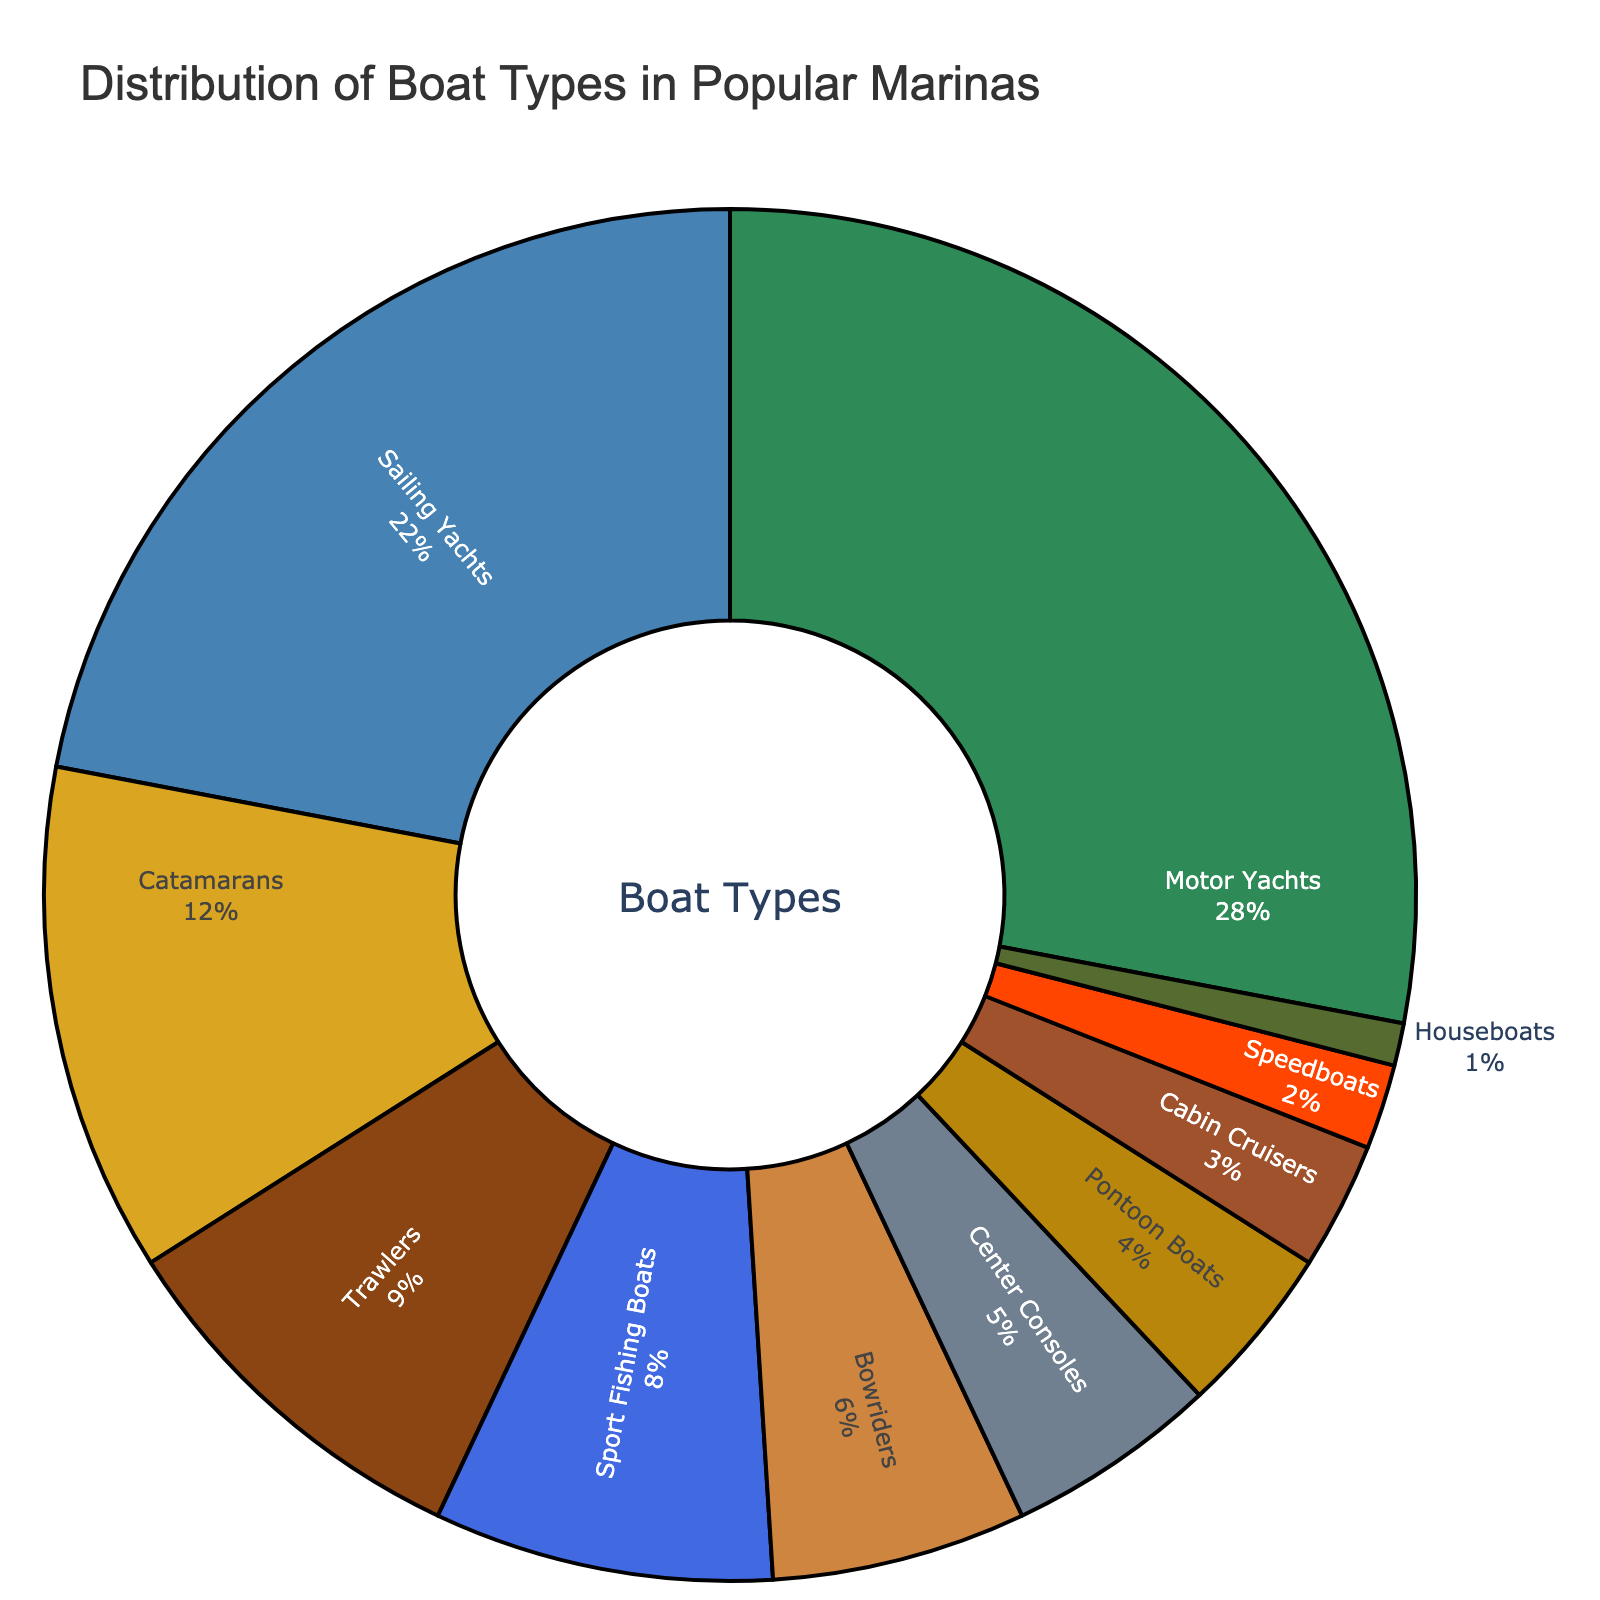Which boat type has the highest percentage? The pie chart shows various boat types with their respective percentages. The sector with the highest value reflects the boat type with the greatest distribution.
Answer: Motor Yachts What is the combined percentage of Sailing Yachts and Catamarans? To find the combined percentage of Sailing Yachts and Catamarans, add the individual percentages: 22% (Sailing Yachts) + 12% (Catamarans) = 34%.
Answer: 34% How much greater is the percentage of Motor Yachts compared to Sport Fishing Boats? Subtract the percentage of Sport Fishing Boats from the percentage of Motor Yachts: 28% (Motor Yachts) - 8% (Sport Fishing Boats) = 20%.
Answer: 20% Which boat type has the second smallest distribution? The pie chart displays all the boat types and their percentages. The second smallest value after Houseboats (1%) is for Speedboats (2%).
Answer: Speedboats Are there more Sailing Yachts or Center Consoles, and by what percentage? Check the individual percentages: Sailing Yachts (22%) and Center Consoles (5%). Subtract 5% from 22% to find the difference: 17%.
Answer: Sailing Yachts by 17% What are the percentages of boat types colored blue and gold? Identify the boat types colored blue and gold in the chart. Blue represents Sailing Yachts (22%) and Bowriders (6%). Gold represents Catamarans (12%) and Pontoon Boats (4%). Sum their percentages: 22% + 6% = 28% for blue and 12% + 4% = 16% for gold.
Answer: Blue: 28%, Gold: 16% If Trawlers and Bowriders were combined into one category, what would be their total percentage? Add the percentages of Trawlers and Bowriders: 9% (Trawlers) + 6% (Bowriders) = 15%.
Answer: 15% Which boat types together make up more than half of the total distribution? Examine the boat types starting with the highest percentage until the sum exceeds 50%. Motor Yachts (28%) + Sailing Yachts (22%) = 50%.
Answer: Motor Yachts and Sailing Yachts Are Houseboats the smallest category, and how many other categories are less than 5%? Check the percentage of Houseboats (1%) and count the categories under 5%: Center Consoles (5%), Pontoon Boats (4%), Cabin Cruisers (3%), Speedboats (2%), and Houseboats (1%) itself. There are four other categories less than 5%.
Answer: Yes, and four What is the difference in percentage between the third and the fifth most distributed boat types? Identify the third (Catamarans: 12%) and the fifth (Sport Fishing Boats: 8%) most distributed boat types. Subtract the fifth from the third: 12% - 8% = 4%.
Answer: 4% 